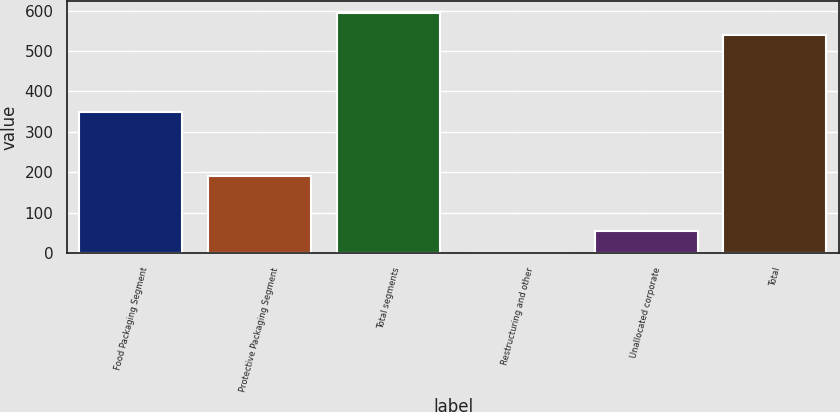Convert chart to OTSL. <chart><loc_0><loc_0><loc_500><loc_500><bar_chart><fcel>Food Packaging Segment<fcel>Protective Packaging Segment<fcel>Total segments<fcel>Restructuring and other<fcel>Unallocated corporate<fcel>Total<nl><fcel>349.2<fcel>191.8<fcel>594.95<fcel>0.5<fcel>54.55<fcel>540.9<nl></chart> 